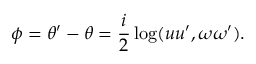Convert formula to latex. <formula><loc_0><loc_0><loc_500><loc_500>\phi = \theta ^ { \prime } - \theta = { \frac { i } { 2 } } \log ( u u ^ { \prime } , \omega \omega ^ { \prime } ) .</formula> 